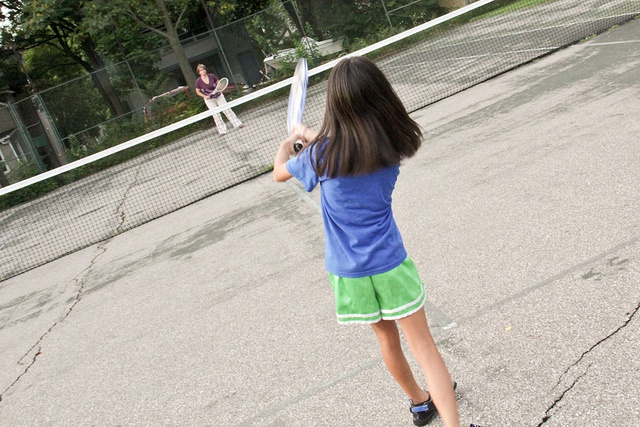Describe the objects in this image and their specific colors. I can see people in white, black, blue, lightgreen, and tan tones, car in white, darkgreen, gray, and black tones, boat in white, darkgray, gray, and darkgreen tones, people in white, lightgray, brown, darkgray, and tan tones, and tennis racket in white, darkgray, and lavender tones in this image. 